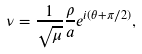<formula> <loc_0><loc_0><loc_500><loc_500>\nu = \frac { 1 } { \sqrt { \mu } } \frac { \rho } { a } e ^ { i ( \theta + \pi / 2 ) } ,</formula> 